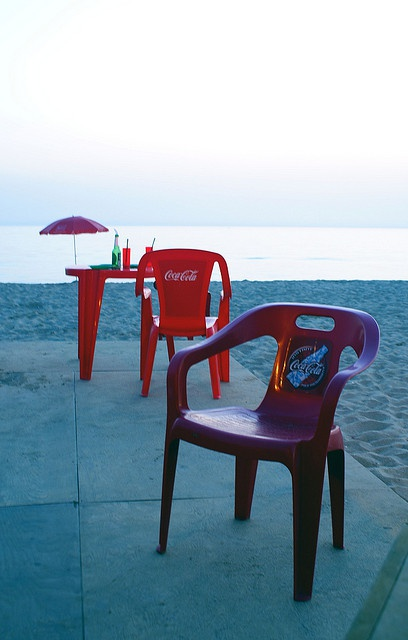Describe the objects in this image and their specific colors. I can see chair in white, black, maroon, and gray tones, chair in white, brown, maroon, teal, and lavender tones, dining table in white, maroon, gray, and black tones, umbrella in white, purple, and violet tones, and bottle in white, teal, lightgreen, and darkgreen tones in this image. 